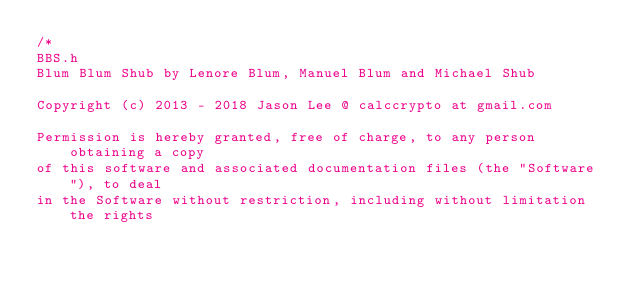<code> <loc_0><loc_0><loc_500><loc_500><_C_>/*
BBS.h
Blum Blum Shub by Lenore Blum, Manuel Blum and Michael Shub

Copyright (c) 2013 - 2018 Jason Lee @ calccrypto at gmail.com

Permission is hereby granted, free of charge, to any person obtaining a copy
of this software and associated documentation files (the "Software"), to deal
in the Software without restriction, including without limitation the rights</code> 